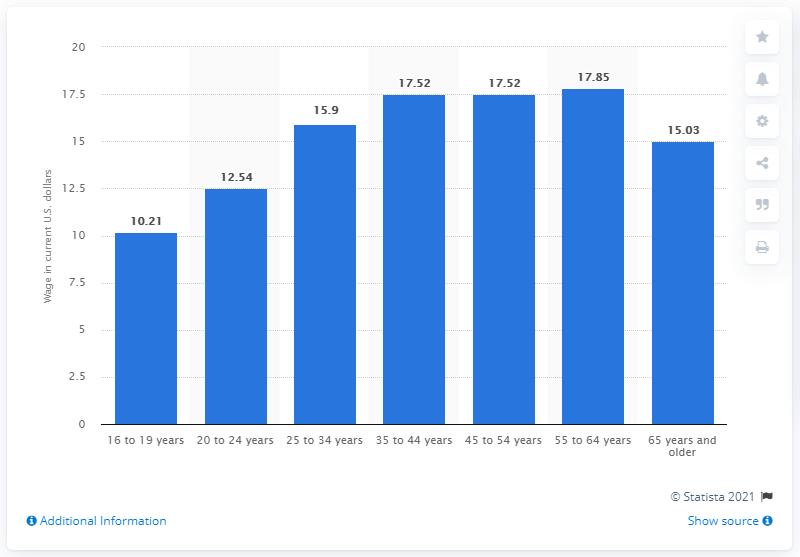Highlight a few significant elements in this photo. The median hourly rate for workers between the ages of 20 and 24 was typically 12.54. 